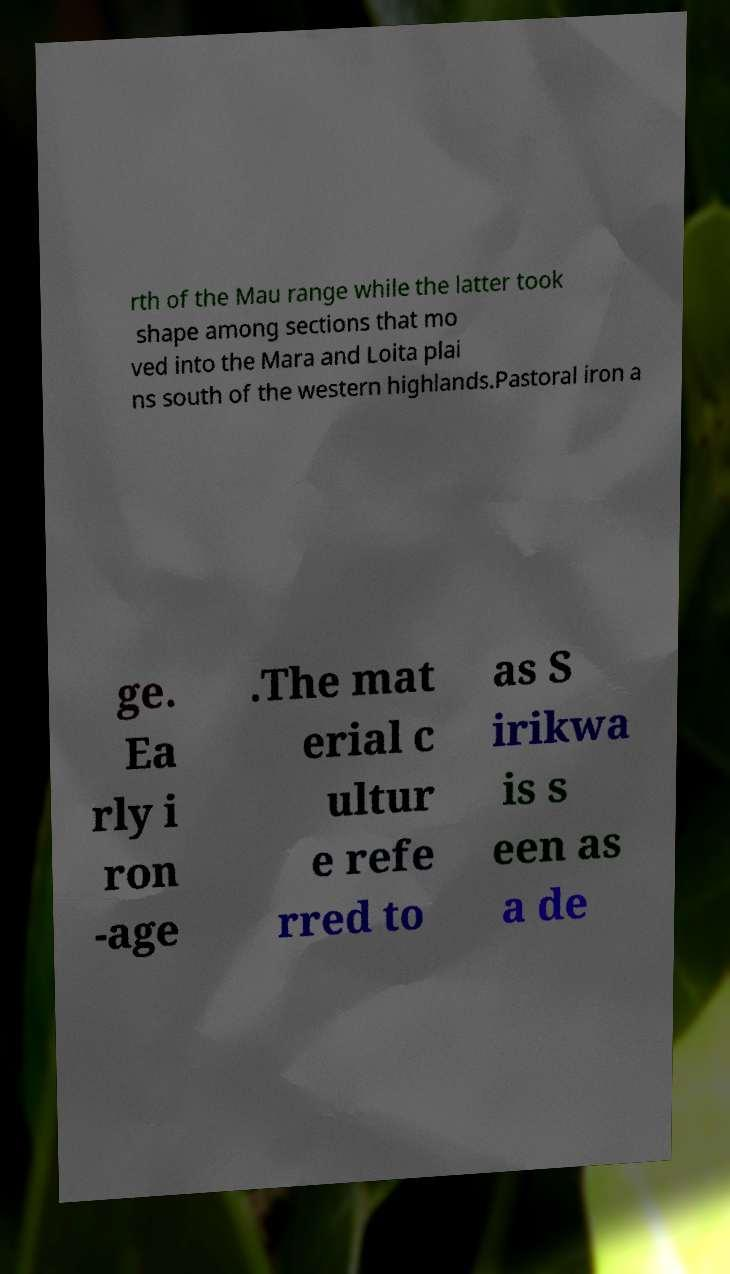I need the written content from this picture converted into text. Can you do that? rth of the Mau range while the latter took shape among sections that mo ved into the Mara and Loita plai ns south of the western highlands.Pastoral iron a ge. Ea rly i ron -age .The mat erial c ultur e refe rred to as S irikwa is s een as a de 